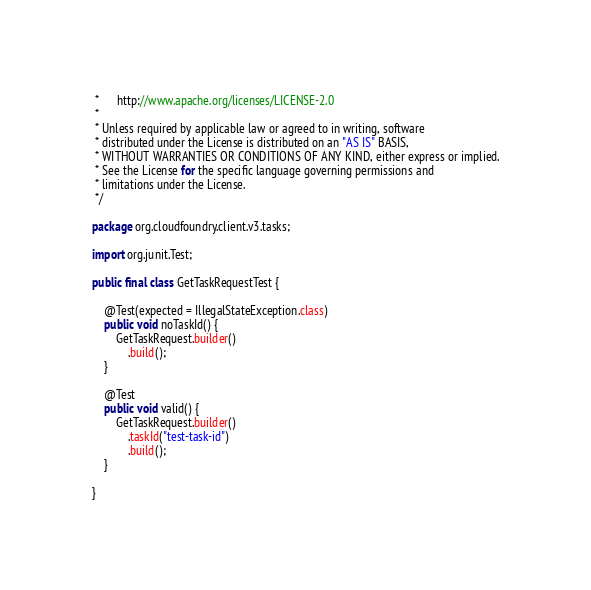Convert code to text. <code><loc_0><loc_0><loc_500><loc_500><_Java_> *      http://www.apache.org/licenses/LICENSE-2.0
 *
 * Unless required by applicable law or agreed to in writing, software
 * distributed under the License is distributed on an "AS IS" BASIS,
 * WITHOUT WARRANTIES OR CONDITIONS OF ANY KIND, either express or implied.
 * See the License for the specific language governing permissions and
 * limitations under the License.
 */

package org.cloudfoundry.client.v3.tasks;

import org.junit.Test;

public final class GetTaskRequestTest {

    @Test(expected = IllegalStateException.class)
    public void noTaskId() {
        GetTaskRequest.builder()
            .build();
    }

    @Test
    public void valid() {
        GetTaskRequest.builder()
            .taskId("test-task-id")
            .build();
    }

}
</code> 